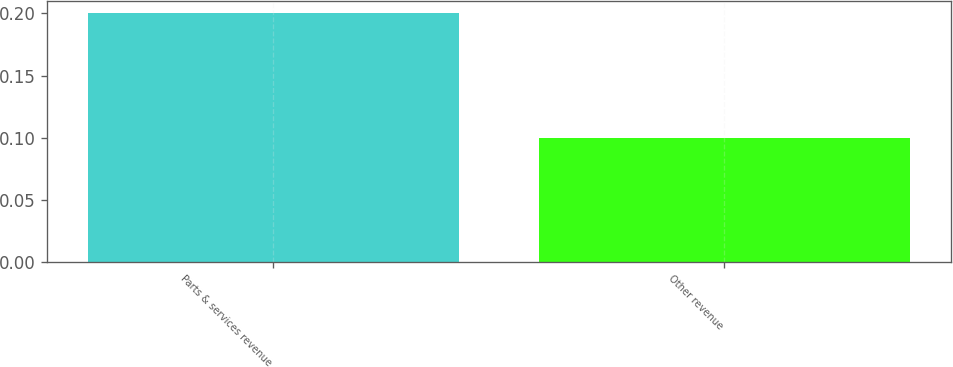Convert chart to OTSL. <chart><loc_0><loc_0><loc_500><loc_500><bar_chart><fcel>Parts & services revenue<fcel>Other revenue<nl><fcel>0.2<fcel>0.1<nl></chart> 